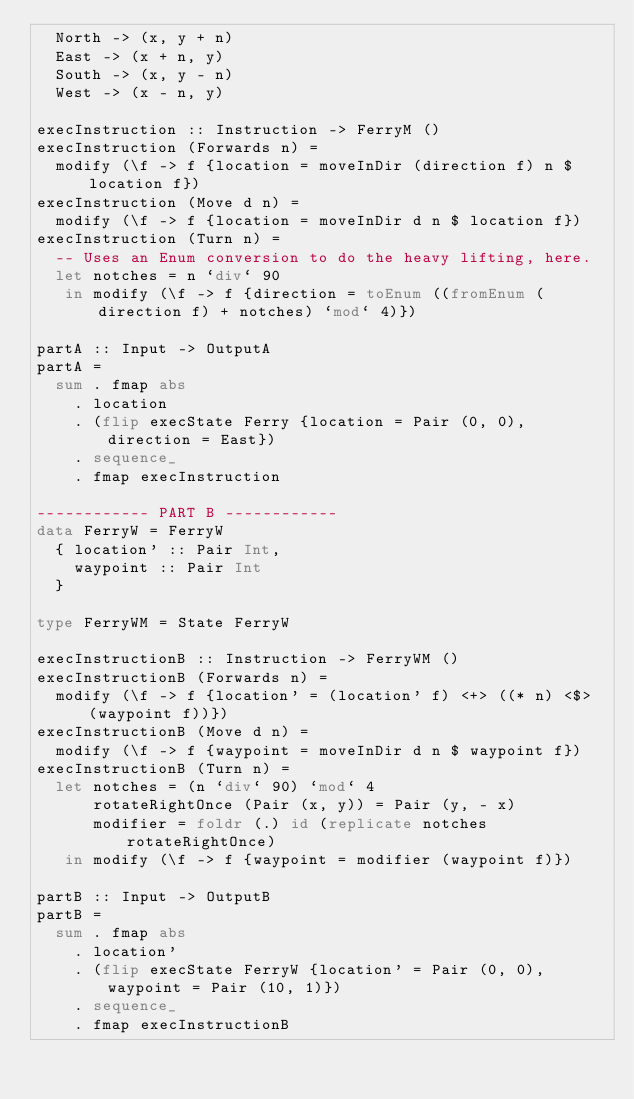<code> <loc_0><loc_0><loc_500><loc_500><_Haskell_>  North -> (x, y + n)
  East -> (x + n, y)
  South -> (x, y - n)
  West -> (x - n, y)

execInstruction :: Instruction -> FerryM ()
execInstruction (Forwards n) =
  modify (\f -> f {location = moveInDir (direction f) n $ location f})
execInstruction (Move d n) =
  modify (\f -> f {location = moveInDir d n $ location f})
execInstruction (Turn n) =
  -- Uses an Enum conversion to do the heavy lifting, here.
  let notches = n `div` 90
   in modify (\f -> f {direction = toEnum ((fromEnum (direction f) + notches) `mod` 4)})

partA :: Input -> OutputA
partA =
  sum . fmap abs
    . location
    . (flip execState Ferry {location = Pair (0, 0), direction = East})
    . sequence_
    . fmap execInstruction

------------ PART B ------------
data FerryW = FerryW
  { location' :: Pair Int,
    waypoint :: Pair Int
  }

type FerryWM = State FerryW

execInstructionB :: Instruction -> FerryWM ()
execInstructionB (Forwards n) =
  modify (\f -> f {location' = (location' f) <+> ((* n) <$> (waypoint f))})
execInstructionB (Move d n) =
  modify (\f -> f {waypoint = moveInDir d n $ waypoint f})
execInstructionB (Turn n) =
  let notches = (n `div` 90) `mod` 4
      rotateRightOnce (Pair (x, y)) = Pair (y, - x)
      modifier = foldr (.) id (replicate notches rotateRightOnce)
   in modify (\f -> f {waypoint = modifier (waypoint f)})

partB :: Input -> OutputB
partB =
  sum . fmap abs
    . location'
    . (flip execState FerryW {location' = Pair (0, 0), waypoint = Pair (10, 1)})
    . sequence_
    . fmap execInstructionB
</code> 